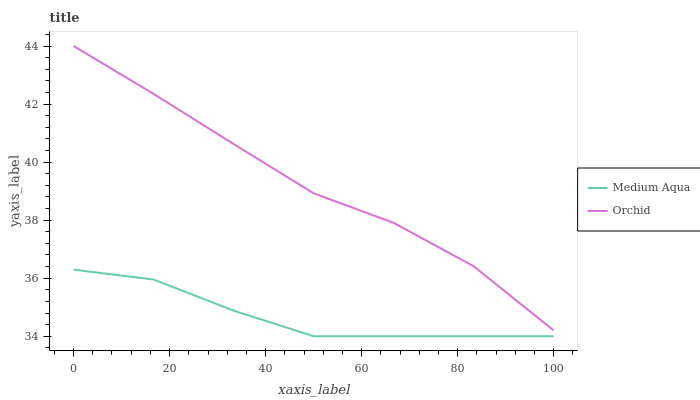Does Medium Aqua have the minimum area under the curve?
Answer yes or no. Yes. Does Orchid have the maximum area under the curve?
Answer yes or no. Yes. Does Orchid have the minimum area under the curve?
Answer yes or no. No. Is Medium Aqua the smoothest?
Answer yes or no. Yes. Is Orchid the roughest?
Answer yes or no. Yes. Is Orchid the smoothest?
Answer yes or no. No. Does Medium Aqua have the lowest value?
Answer yes or no. Yes. Does Orchid have the lowest value?
Answer yes or no. No. Does Orchid have the highest value?
Answer yes or no. Yes. Is Medium Aqua less than Orchid?
Answer yes or no. Yes. Is Orchid greater than Medium Aqua?
Answer yes or no. Yes. Does Medium Aqua intersect Orchid?
Answer yes or no. No. 